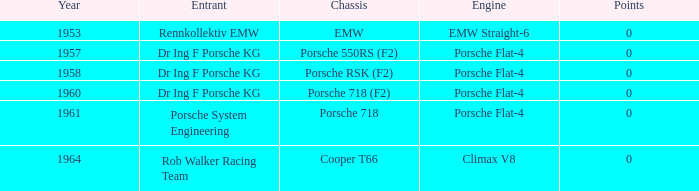In which year were there over 0 points? 0.0. 